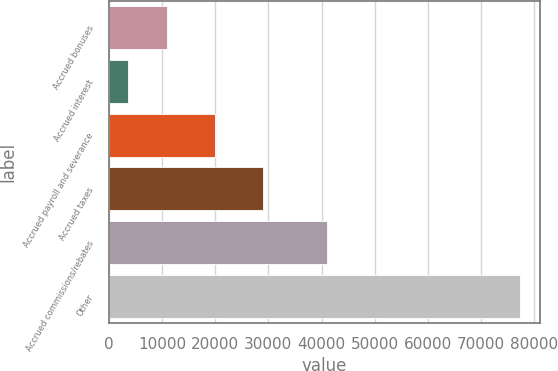Convert chart to OTSL. <chart><loc_0><loc_0><loc_500><loc_500><bar_chart><fcel>Accrued bonuses<fcel>Accrued interest<fcel>Accrued payroll and severance<fcel>Accrued taxes<fcel>Accrued commissions/rebates<fcel>Other<nl><fcel>10923.9<fcel>3558<fcel>19958<fcel>28974<fcel>40991<fcel>77217<nl></chart> 